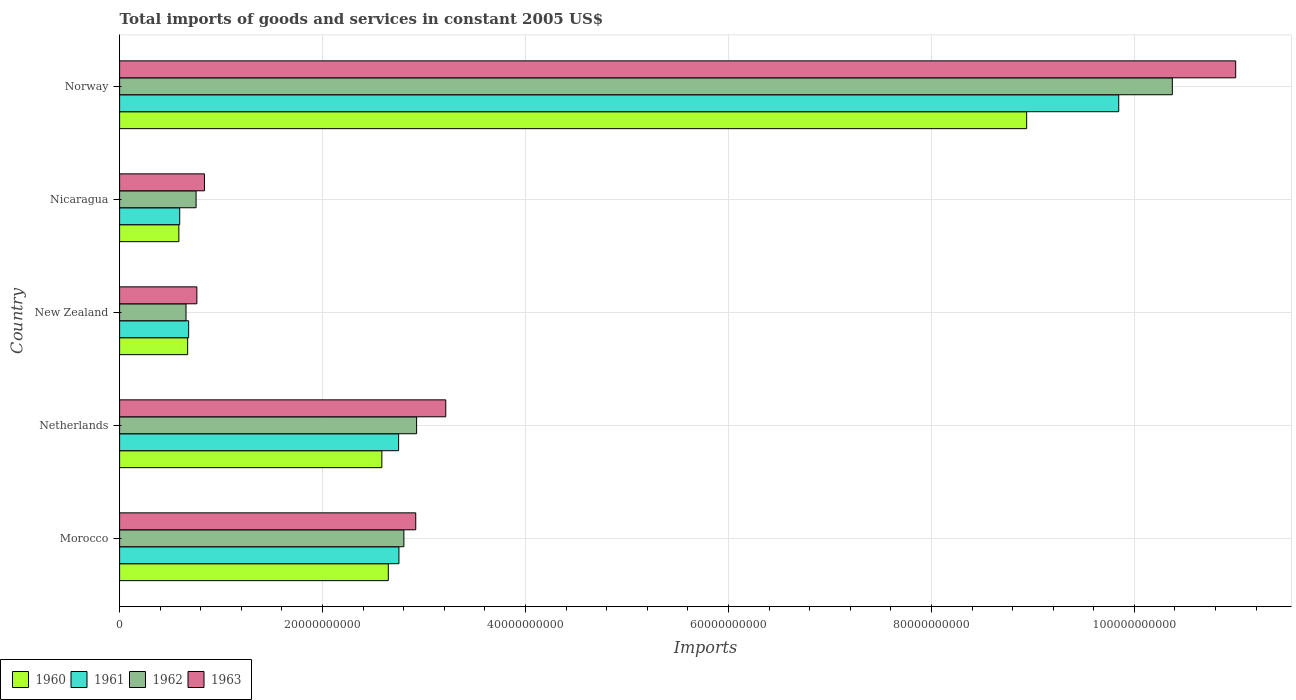Are the number of bars on each tick of the Y-axis equal?
Give a very brief answer. Yes. How many bars are there on the 2nd tick from the top?
Make the answer very short. 4. What is the label of the 1st group of bars from the top?
Your answer should be compact. Norway. What is the total imports of goods and services in 1960 in Nicaragua?
Your answer should be compact. 5.84e+09. Across all countries, what is the maximum total imports of goods and services in 1960?
Make the answer very short. 8.94e+1. Across all countries, what is the minimum total imports of goods and services in 1960?
Offer a very short reply. 5.84e+09. In which country was the total imports of goods and services in 1961 maximum?
Offer a terse response. Norway. In which country was the total imports of goods and services in 1961 minimum?
Provide a short and direct response. Nicaragua. What is the total total imports of goods and services in 1962 in the graph?
Give a very brief answer. 1.75e+11. What is the difference between the total imports of goods and services in 1963 in Morocco and that in Norway?
Your answer should be compact. -8.08e+1. What is the difference between the total imports of goods and services in 1962 in Nicaragua and the total imports of goods and services in 1960 in Norway?
Provide a short and direct response. -8.19e+1. What is the average total imports of goods and services in 1962 per country?
Keep it short and to the point. 3.50e+1. What is the difference between the total imports of goods and services in 1961 and total imports of goods and services in 1963 in Netherlands?
Ensure brevity in your answer.  -4.65e+09. In how many countries, is the total imports of goods and services in 1961 greater than 88000000000 US$?
Your response must be concise. 1. What is the ratio of the total imports of goods and services in 1963 in Netherlands to that in Norway?
Provide a short and direct response. 0.29. What is the difference between the highest and the second highest total imports of goods and services in 1960?
Your answer should be compact. 6.29e+1. What is the difference between the highest and the lowest total imports of goods and services in 1962?
Your answer should be compact. 9.72e+1. In how many countries, is the total imports of goods and services in 1961 greater than the average total imports of goods and services in 1961 taken over all countries?
Provide a short and direct response. 1. What does the 2nd bar from the top in New Zealand represents?
Keep it short and to the point. 1962. Are all the bars in the graph horizontal?
Your response must be concise. Yes. Are the values on the major ticks of X-axis written in scientific E-notation?
Provide a short and direct response. No. Does the graph contain any zero values?
Give a very brief answer. No. Does the graph contain grids?
Offer a terse response. Yes. Where does the legend appear in the graph?
Make the answer very short. Bottom left. How many legend labels are there?
Ensure brevity in your answer.  4. How are the legend labels stacked?
Offer a terse response. Horizontal. What is the title of the graph?
Make the answer very short. Total imports of goods and services in constant 2005 US$. Does "2000" appear as one of the legend labels in the graph?
Give a very brief answer. No. What is the label or title of the X-axis?
Provide a short and direct response. Imports. What is the Imports in 1960 in Morocco?
Your answer should be very brief. 2.65e+1. What is the Imports in 1961 in Morocco?
Your answer should be compact. 2.75e+1. What is the Imports of 1962 in Morocco?
Provide a succinct answer. 2.80e+1. What is the Imports of 1963 in Morocco?
Ensure brevity in your answer.  2.92e+1. What is the Imports in 1960 in Netherlands?
Your answer should be compact. 2.58e+1. What is the Imports of 1961 in Netherlands?
Offer a terse response. 2.75e+1. What is the Imports of 1962 in Netherlands?
Provide a short and direct response. 2.93e+1. What is the Imports in 1963 in Netherlands?
Your response must be concise. 3.21e+1. What is the Imports of 1960 in New Zealand?
Offer a very short reply. 6.71e+09. What is the Imports in 1961 in New Zealand?
Make the answer very short. 6.81e+09. What is the Imports in 1962 in New Zealand?
Offer a very short reply. 6.55e+09. What is the Imports in 1963 in New Zealand?
Make the answer very short. 7.62e+09. What is the Imports in 1960 in Nicaragua?
Your answer should be compact. 5.84e+09. What is the Imports in 1961 in Nicaragua?
Give a very brief answer. 5.92e+09. What is the Imports in 1962 in Nicaragua?
Ensure brevity in your answer.  7.54e+09. What is the Imports of 1963 in Nicaragua?
Keep it short and to the point. 8.36e+09. What is the Imports in 1960 in Norway?
Provide a short and direct response. 8.94e+1. What is the Imports in 1961 in Norway?
Make the answer very short. 9.85e+1. What is the Imports of 1962 in Norway?
Give a very brief answer. 1.04e+11. What is the Imports of 1963 in Norway?
Offer a very short reply. 1.10e+11. Across all countries, what is the maximum Imports in 1960?
Give a very brief answer. 8.94e+1. Across all countries, what is the maximum Imports of 1961?
Your answer should be compact. 9.85e+1. Across all countries, what is the maximum Imports in 1962?
Provide a succinct answer. 1.04e+11. Across all countries, what is the maximum Imports in 1963?
Give a very brief answer. 1.10e+11. Across all countries, what is the minimum Imports in 1960?
Your response must be concise. 5.84e+09. Across all countries, what is the minimum Imports in 1961?
Keep it short and to the point. 5.92e+09. Across all countries, what is the minimum Imports in 1962?
Offer a terse response. 6.55e+09. Across all countries, what is the minimum Imports of 1963?
Keep it short and to the point. 7.62e+09. What is the total Imports in 1960 in the graph?
Ensure brevity in your answer.  1.54e+11. What is the total Imports of 1961 in the graph?
Your response must be concise. 1.66e+11. What is the total Imports in 1962 in the graph?
Make the answer very short. 1.75e+11. What is the total Imports in 1963 in the graph?
Make the answer very short. 1.87e+11. What is the difference between the Imports of 1960 in Morocco and that in Netherlands?
Your answer should be compact. 6.37e+08. What is the difference between the Imports in 1961 in Morocco and that in Netherlands?
Provide a short and direct response. 3.12e+07. What is the difference between the Imports of 1962 in Morocco and that in Netherlands?
Provide a succinct answer. -1.25e+09. What is the difference between the Imports of 1963 in Morocco and that in Netherlands?
Make the answer very short. -2.96e+09. What is the difference between the Imports in 1960 in Morocco and that in New Zealand?
Give a very brief answer. 1.98e+1. What is the difference between the Imports of 1961 in Morocco and that in New Zealand?
Give a very brief answer. 2.07e+1. What is the difference between the Imports of 1962 in Morocco and that in New Zealand?
Give a very brief answer. 2.15e+1. What is the difference between the Imports in 1963 in Morocco and that in New Zealand?
Keep it short and to the point. 2.16e+1. What is the difference between the Imports in 1960 in Morocco and that in Nicaragua?
Make the answer very short. 2.06e+1. What is the difference between the Imports of 1961 in Morocco and that in Nicaragua?
Your response must be concise. 2.16e+1. What is the difference between the Imports in 1962 in Morocco and that in Nicaragua?
Provide a succinct answer. 2.05e+1. What is the difference between the Imports of 1963 in Morocco and that in Nicaragua?
Offer a very short reply. 2.08e+1. What is the difference between the Imports in 1960 in Morocco and that in Norway?
Offer a terse response. -6.29e+1. What is the difference between the Imports in 1961 in Morocco and that in Norway?
Keep it short and to the point. -7.09e+1. What is the difference between the Imports of 1962 in Morocco and that in Norway?
Your answer should be very brief. -7.57e+1. What is the difference between the Imports in 1963 in Morocco and that in Norway?
Your response must be concise. -8.08e+1. What is the difference between the Imports of 1960 in Netherlands and that in New Zealand?
Provide a succinct answer. 1.91e+1. What is the difference between the Imports in 1961 in Netherlands and that in New Zealand?
Provide a short and direct response. 2.07e+1. What is the difference between the Imports in 1962 in Netherlands and that in New Zealand?
Make the answer very short. 2.27e+1. What is the difference between the Imports in 1963 in Netherlands and that in New Zealand?
Provide a succinct answer. 2.45e+1. What is the difference between the Imports in 1960 in Netherlands and that in Nicaragua?
Make the answer very short. 2.00e+1. What is the difference between the Imports in 1961 in Netherlands and that in Nicaragua?
Give a very brief answer. 2.16e+1. What is the difference between the Imports in 1962 in Netherlands and that in Nicaragua?
Provide a short and direct response. 2.17e+1. What is the difference between the Imports in 1963 in Netherlands and that in Nicaragua?
Your response must be concise. 2.38e+1. What is the difference between the Imports of 1960 in Netherlands and that in Norway?
Give a very brief answer. -6.35e+1. What is the difference between the Imports of 1961 in Netherlands and that in Norway?
Make the answer very short. -7.10e+1. What is the difference between the Imports in 1962 in Netherlands and that in Norway?
Offer a terse response. -7.45e+1. What is the difference between the Imports in 1963 in Netherlands and that in Norway?
Your answer should be compact. -7.78e+1. What is the difference between the Imports in 1960 in New Zealand and that in Nicaragua?
Offer a very short reply. 8.66e+08. What is the difference between the Imports of 1961 in New Zealand and that in Nicaragua?
Offer a terse response. 8.81e+08. What is the difference between the Imports of 1962 in New Zealand and that in Nicaragua?
Offer a terse response. -9.91e+08. What is the difference between the Imports of 1963 in New Zealand and that in Nicaragua?
Provide a succinct answer. -7.46e+08. What is the difference between the Imports in 1960 in New Zealand and that in Norway?
Give a very brief answer. -8.27e+1. What is the difference between the Imports in 1961 in New Zealand and that in Norway?
Provide a succinct answer. -9.17e+1. What is the difference between the Imports in 1962 in New Zealand and that in Norway?
Offer a very short reply. -9.72e+1. What is the difference between the Imports in 1963 in New Zealand and that in Norway?
Ensure brevity in your answer.  -1.02e+11. What is the difference between the Imports of 1960 in Nicaragua and that in Norway?
Your response must be concise. -8.35e+1. What is the difference between the Imports in 1961 in Nicaragua and that in Norway?
Provide a short and direct response. -9.25e+1. What is the difference between the Imports in 1962 in Nicaragua and that in Norway?
Provide a succinct answer. -9.62e+1. What is the difference between the Imports of 1963 in Nicaragua and that in Norway?
Your answer should be very brief. -1.02e+11. What is the difference between the Imports in 1960 in Morocco and the Imports in 1961 in Netherlands?
Make the answer very short. -1.02e+09. What is the difference between the Imports in 1960 in Morocco and the Imports in 1962 in Netherlands?
Offer a very short reply. -2.79e+09. What is the difference between the Imports of 1960 in Morocco and the Imports of 1963 in Netherlands?
Give a very brief answer. -5.66e+09. What is the difference between the Imports in 1961 in Morocco and the Imports in 1962 in Netherlands?
Your answer should be compact. -1.74e+09. What is the difference between the Imports in 1961 in Morocco and the Imports in 1963 in Netherlands?
Ensure brevity in your answer.  -4.62e+09. What is the difference between the Imports in 1962 in Morocco and the Imports in 1963 in Netherlands?
Your response must be concise. -4.13e+09. What is the difference between the Imports of 1960 in Morocco and the Imports of 1961 in New Zealand?
Offer a very short reply. 1.97e+1. What is the difference between the Imports of 1960 in Morocco and the Imports of 1962 in New Zealand?
Your answer should be compact. 1.99e+1. What is the difference between the Imports of 1960 in Morocco and the Imports of 1963 in New Zealand?
Keep it short and to the point. 1.89e+1. What is the difference between the Imports of 1961 in Morocco and the Imports of 1962 in New Zealand?
Offer a terse response. 2.10e+1. What is the difference between the Imports of 1961 in Morocco and the Imports of 1963 in New Zealand?
Your answer should be very brief. 1.99e+1. What is the difference between the Imports in 1962 in Morocco and the Imports in 1963 in New Zealand?
Offer a very short reply. 2.04e+1. What is the difference between the Imports of 1960 in Morocco and the Imports of 1961 in Nicaragua?
Your response must be concise. 2.06e+1. What is the difference between the Imports of 1960 in Morocco and the Imports of 1962 in Nicaragua?
Give a very brief answer. 1.89e+1. What is the difference between the Imports of 1960 in Morocco and the Imports of 1963 in Nicaragua?
Keep it short and to the point. 1.81e+1. What is the difference between the Imports of 1961 in Morocco and the Imports of 1962 in Nicaragua?
Keep it short and to the point. 2.00e+1. What is the difference between the Imports in 1961 in Morocco and the Imports in 1963 in Nicaragua?
Offer a very short reply. 1.92e+1. What is the difference between the Imports in 1962 in Morocco and the Imports in 1963 in Nicaragua?
Give a very brief answer. 1.97e+1. What is the difference between the Imports of 1960 in Morocco and the Imports of 1961 in Norway?
Your response must be concise. -7.20e+1. What is the difference between the Imports of 1960 in Morocco and the Imports of 1962 in Norway?
Your response must be concise. -7.73e+1. What is the difference between the Imports in 1960 in Morocco and the Imports in 1963 in Norway?
Your response must be concise. -8.35e+1. What is the difference between the Imports of 1961 in Morocco and the Imports of 1962 in Norway?
Make the answer very short. -7.62e+1. What is the difference between the Imports in 1961 in Morocco and the Imports in 1963 in Norway?
Provide a short and direct response. -8.25e+1. What is the difference between the Imports in 1962 in Morocco and the Imports in 1963 in Norway?
Ensure brevity in your answer.  -8.20e+1. What is the difference between the Imports in 1960 in Netherlands and the Imports in 1961 in New Zealand?
Offer a very short reply. 1.90e+1. What is the difference between the Imports in 1960 in Netherlands and the Imports in 1962 in New Zealand?
Offer a very short reply. 1.93e+1. What is the difference between the Imports of 1960 in Netherlands and the Imports of 1963 in New Zealand?
Provide a short and direct response. 1.82e+1. What is the difference between the Imports in 1961 in Netherlands and the Imports in 1962 in New Zealand?
Your answer should be compact. 2.10e+1. What is the difference between the Imports in 1961 in Netherlands and the Imports in 1963 in New Zealand?
Offer a terse response. 1.99e+1. What is the difference between the Imports in 1962 in Netherlands and the Imports in 1963 in New Zealand?
Provide a succinct answer. 2.17e+1. What is the difference between the Imports in 1960 in Netherlands and the Imports in 1961 in Nicaragua?
Offer a terse response. 1.99e+1. What is the difference between the Imports of 1960 in Netherlands and the Imports of 1962 in Nicaragua?
Your answer should be compact. 1.83e+1. What is the difference between the Imports in 1960 in Netherlands and the Imports in 1963 in Nicaragua?
Your answer should be very brief. 1.75e+1. What is the difference between the Imports in 1961 in Netherlands and the Imports in 1962 in Nicaragua?
Your response must be concise. 2.00e+1. What is the difference between the Imports in 1961 in Netherlands and the Imports in 1963 in Nicaragua?
Provide a short and direct response. 1.91e+1. What is the difference between the Imports in 1962 in Netherlands and the Imports in 1963 in Nicaragua?
Provide a succinct answer. 2.09e+1. What is the difference between the Imports of 1960 in Netherlands and the Imports of 1961 in Norway?
Your answer should be very brief. -7.26e+1. What is the difference between the Imports of 1960 in Netherlands and the Imports of 1962 in Norway?
Give a very brief answer. -7.79e+1. What is the difference between the Imports in 1960 in Netherlands and the Imports in 1963 in Norway?
Make the answer very short. -8.41e+1. What is the difference between the Imports in 1961 in Netherlands and the Imports in 1962 in Norway?
Provide a succinct answer. -7.62e+1. What is the difference between the Imports of 1961 in Netherlands and the Imports of 1963 in Norway?
Your answer should be compact. -8.25e+1. What is the difference between the Imports of 1962 in Netherlands and the Imports of 1963 in Norway?
Provide a short and direct response. -8.07e+1. What is the difference between the Imports in 1960 in New Zealand and the Imports in 1961 in Nicaragua?
Give a very brief answer. 7.83e+08. What is the difference between the Imports of 1960 in New Zealand and the Imports of 1962 in Nicaragua?
Your answer should be very brief. -8.30e+08. What is the difference between the Imports of 1960 in New Zealand and the Imports of 1963 in Nicaragua?
Your answer should be compact. -1.66e+09. What is the difference between the Imports of 1961 in New Zealand and the Imports of 1962 in Nicaragua?
Provide a short and direct response. -7.32e+08. What is the difference between the Imports in 1961 in New Zealand and the Imports in 1963 in Nicaragua?
Provide a short and direct response. -1.56e+09. What is the difference between the Imports of 1962 in New Zealand and the Imports of 1963 in Nicaragua?
Give a very brief answer. -1.82e+09. What is the difference between the Imports of 1960 in New Zealand and the Imports of 1961 in Norway?
Keep it short and to the point. -9.18e+1. What is the difference between the Imports of 1960 in New Zealand and the Imports of 1962 in Norway?
Keep it short and to the point. -9.70e+1. What is the difference between the Imports in 1960 in New Zealand and the Imports in 1963 in Norway?
Ensure brevity in your answer.  -1.03e+11. What is the difference between the Imports in 1961 in New Zealand and the Imports in 1962 in Norway?
Your answer should be compact. -9.69e+1. What is the difference between the Imports in 1961 in New Zealand and the Imports in 1963 in Norway?
Provide a succinct answer. -1.03e+11. What is the difference between the Imports in 1962 in New Zealand and the Imports in 1963 in Norway?
Your answer should be compact. -1.03e+11. What is the difference between the Imports in 1960 in Nicaragua and the Imports in 1961 in Norway?
Make the answer very short. -9.26e+1. What is the difference between the Imports in 1960 in Nicaragua and the Imports in 1962 in Norway?
Keep it short and to the point. -9.79e+1. What is the difference between the Imports in 1960 in Nicaragua and the Imports in 1963 in Norway?
Make the answer very short. -1.04e+11. What is the difference between the Imports in 1961 in Nicaragua and the Imports in 1962 in Norway?
Ensure brevity in your answer.  -9.78e+1. What is the difference between the Imports of 1961 in Nicaragua and the Imports of 1963 in Norway?
Make the answer very short. -1.04e+11. What is the difference between the Imports of 1962 in Nicaragua and the Imports of 1963 in Norway?
Offer a very short reply. -1.02e+11. What is the average Imports in 1960 per country?
Offer a very short reply. 3.09e+1. What is the average Imports of 1961 per country?
Your answer should be very brief. 3.32e+1. What is the average Imports in 1962 per country?
Make the answer very short. 3.50e+1. What is the average Imports of 1963 per country?
Offer a very short reply. 3.75e+1. What is the difference between the Imports of 1960 and Imports of 1961 in Morocco?
Offer a very short reply. -1.05e+09. What is the difference between the Imports of 1960 and Imports of 1962 in Morocco?
Provide a short and direct response. -1.54e+09. What is the difference between the Imports of 1960 and Imports of 1963 in Morocco?
Offer a terse response. -2.70e+09. What is the difference between the Imports in 1961 and Imports in 1962 in Morocco?
Offer a terse response. -4.88e+08. What is the difference between the Imports in 1961 and Imports in 1963 in Morocco?
Give a very brief answer. -1.66e+09. What is the difference between the Imports of 1962 and Imports of 1963 in Morocco?
Keep it short and to the point. -1.17e+09. What is the difference between the Imports in 1960 and Imports in 1961 in Netherlands?
Your answer should be very brief. -1.65e+09. What is the difference between the Imports in 1960 and Imports in 1962 in Netherlands?
Your answer should be very brief. -3.43e+09. What is the difference between the Imports in 1960 and Imports in 1963 in Netherlands?
Make the answer very short. -6.30e+09. What is the difference between the Imports of 1961 and Imports of 1962 in Netherlands?
Ensure brevity in your answer.  -1.77e+09. What is the difference between the Imports in 1961 and Imports in 1963 in Netherlands?
Keep it short and to the point. -4.65e+09. What is the difference between the Imports of 1962 and Imports of 1963 in Netherlands?
Your response must be concise. -2.87e+09. What is the difference between the Imports of 1960 and Imports of 1961 in New Zealand?
Ensure brevity in your answer.  -9.87e+07. What is the difference between the Imports in 1960 and Imports in 1962 in New Zealand?
Provide a succinct answer. 1.61e+08. What is the difference between the Imports of 1960 and Imports of 1963 in New Zealand?
Your answer should be very brief. -9.09e+08. What is the difference between the Imports of 1961 and Imports of 1962 in New Zealand?
Provide a short and direct response. 2.60e+08. What is the difference between the Imports of 1961 and Imports of 1963 in New Zealand?
Ensure brevity in your answer.  -8.10e+08. What is the difference between the Imports in 1962 and Imports in 1963 in New Zealand?
Make the answer very short. -1.07e+09. What is the difference between the Imports in 1960 and Imports in 1961 in Nicaragua?
Provide a short and direct response. -8.34e+07. What is the difference between the Imports of 1960 and Imports of 1962 in Nicaragua?
Ensure brevity in your answer.  -1.70e+09. What is the difference between the Imports of 1960 and Imports of 1963 in Nicaragua?
Offer a very short reply. -2.52e+09. What is the difference between the Imports of 1961 and Imports of 1962 in Nicaragua?
Make the answer very short. -1.61e+09. What is the difference between the Imports in 1961 and Imports in 1963 in Nicaragua?
Make the answer very short. -2.44e+09. What is the difference between the Imports in 1962 and Imports in 1963 in Nicaragua?
Your response must be concise. -8.25e+08. What is the difference between the Imports in 1960 and Imports in 1961 in Norway?
Your answer should be very brief. -9.07e+09. What is the difference between the Imports of 1960 and Imports of 1962 in Norway?
Your answer should be very brief. -1.44e+1. What is the difference between the Imports in 1960 and Imports in 1963 in Norway?
Offer a very short reply. -2.06e+1. What is the difference between the Imports in 1961 and Imports in 1962 in Norway?
Keep it short and to the point. -5.28e+09. What is the difference between the Imports in 1961 and Imports in 1963 in Norway?
Give a very brief answer. -1.15e+1. What is the difference between the Imports of 1962 and Imports of 1963 in Norway?
Keep it short and to the point. -6.24e+09. What is the ratio of the Imports of 1960 in Morocco to that in Netherlands?
Ensure brevity in your answer.  1.02. What is the ratio of the Imports of 1962 in Morocco to that in Netherlands?
Provide a short and direct response. 0.96. What is the ratio of the Imports in 1963 in Morocco to that in Netherlands?
Ensure brevity in your answer.  0.91. What is the ratio of the Imports in 1960 in Morocco to that in New Zealand?
Offer a very short reply. 3.95. What is the ratio of the Imports of 1961 in Morocco to that in New Zealand?
Make the answer very short. 4.04. What is the ratio of the Imports of 1962 in Morocco to that in New Zealand?
Give a very brief answer. 4.28. What is the ratio of the Imports of 1963 in Morocco to that in New Zealand?
Your answer should be compact. 3.83. What is the ratio of the Imports of 1960 in Morocco to that in Nicaragua?
Provide a succinct answer. 4.53. What is the ratio of the Imports in 1961 in Morocco to that in Nicaragua?
Offer a terse response. 4.65. What is the ratio of the Imports of 1962 in Morocco to that in Nicaragua?
Your answer should be compact. 3.72. What is the ratio of the Imports in 1963 in Morocco to that in Nicaragua?
Your answer should be compact. 3.49. What is the ratio of the Imports of 1960 in Morocco to that in Norway?
Offer a very short reply. 0.3. What is the ratio of the Imports of 1961 in Morocco to that in Norway?
Give a very brief answer. 0.28. What is the ratio of the Imports in 1962 in Morocco to that in Norway?
Offer a terse response. 0.27. What is the ratio of the Imports of 1963 in Morocco to that in Norway?
Your answer should be very brief. 0.27. What is the ratio of the Imports of 1960 in Netherlands to that in New Zealand?
Your answer should be very brief. 3.85. What is the ratio of the Imports of 1961 in Netherlands to that in New Zealand?
Offer a very short reply. 4.04. What is the ratio of the Imports in 1962 in Netherlands to that in New Zealand?
Your response must be concise. 4.47. What is the ratio of the Imports of 1963 in Netherlands to that in New Zealand?
Offer a very short reply. 4.22. What is the ratio of the Imports in 1960 in Netherlands to that in Nicaragua?
Make the answer very short. 4.42. What is the ratio of the Imports of 1961 in Netherlands to that in Nicaragua?
Make the answer very short. 4.64. What is the ratio of the Imports of 1962 in Netherlands to that in Nicaragua?
Provide a short and direct response. 3.88. What is the ratio of the Imports of 1963 in Netherlands to that in Nicaragua?
Make the answer very short. 3.84. What is the ratio of the Imports of 1960 in Netherlands to that in Norway?
Offer a very short reply. 0.29. What is the ratio of the Imports of 1961 in Netherlands to that in Norway?
Ensure brevity in your answer.  0.28. What is the ratio of the Imports of 1962 in Netherlands to that in Norway?
Ensure brevity in your answer.  0.28. What is the ratio of the Imports of 1963 in Netherlands to that in Norway?
Provide a short and direct response. 0.29. What is the ratio of the Imports in 1960 in New Zealand to that in Nicaragua?
Ensure brevity in your answer.  1.15. What is the ratio of the Imports in 1961 in New Zealand to that in Nicaragua?
Provide a succinct answer. 1.15. What is the ratio of the Imports of 1962 in New Zealand to that in Nicaragua?
Ensure brevity in your answer.  0.87. What is the ratio of the Imports of 1963 in New Zealand to that in Nicaragua?
Provide a succinct answer. 0.91. What is the ratio of the Imports in 1960 in New Zealand to that in Norway?
Give a very brief answer. 0.07. What is the ratio of the Imports of 1961 in New Zealand to that in Norway?
Your response must be concise. 0.07. What is the ratio of the Imports in 1962 in New Zealand to that in Norway?
Keep it short and to the point. 0.06. What is the ratio of the Imports of 1963 in New Zealand to that in Norway?
Ensure brevity in your answer.  0.07. What is the ratio of the Imports of 1960 in Nicaragua to that in Norway?
Provide a succinct answer. 0.07. What is the ratio of the Imports in 1961 in Nicaragua to that in Norway?
Your response must be concise. 0.06. What is the ratio of the Imports in 1962 in Nicaragua to that in Norway?
Your answer should be very brief. 0.07. What is the ratio of the Imports of 1963 in Nicaragua to that in Norway?
Your response must be concise. 0.08. What is the difference between the highest and the second highest Imports in 1960?
Your answer should be compact. 6.29e+1. What is the difference between the highest and the second highest Imports of 1961?
Provide a short and direct response. 7.09e+1. What is the difference between the highest and the second highest Imports in 1962?
Give a very brief answer. 7.45e+1. What is the difference between the highest and the second highest Imports in 1963?
Provide a succinct answer. 7.78e+1. What is the difference between the highest and the lowest Imports of 1960?
Keep it short and to the point. 8.35e+1. What is the difference between the highest and the lowest Imports of 1961?
Make the answer very short. 9.25e+1. What is the difference between the highest and the lowest Imports of 1962?
Offer a terse response. 9.72e+1. What is the difference between the highest and the lowest Imports of 1963?
Provide a short and direct response. 1.02e+11. 